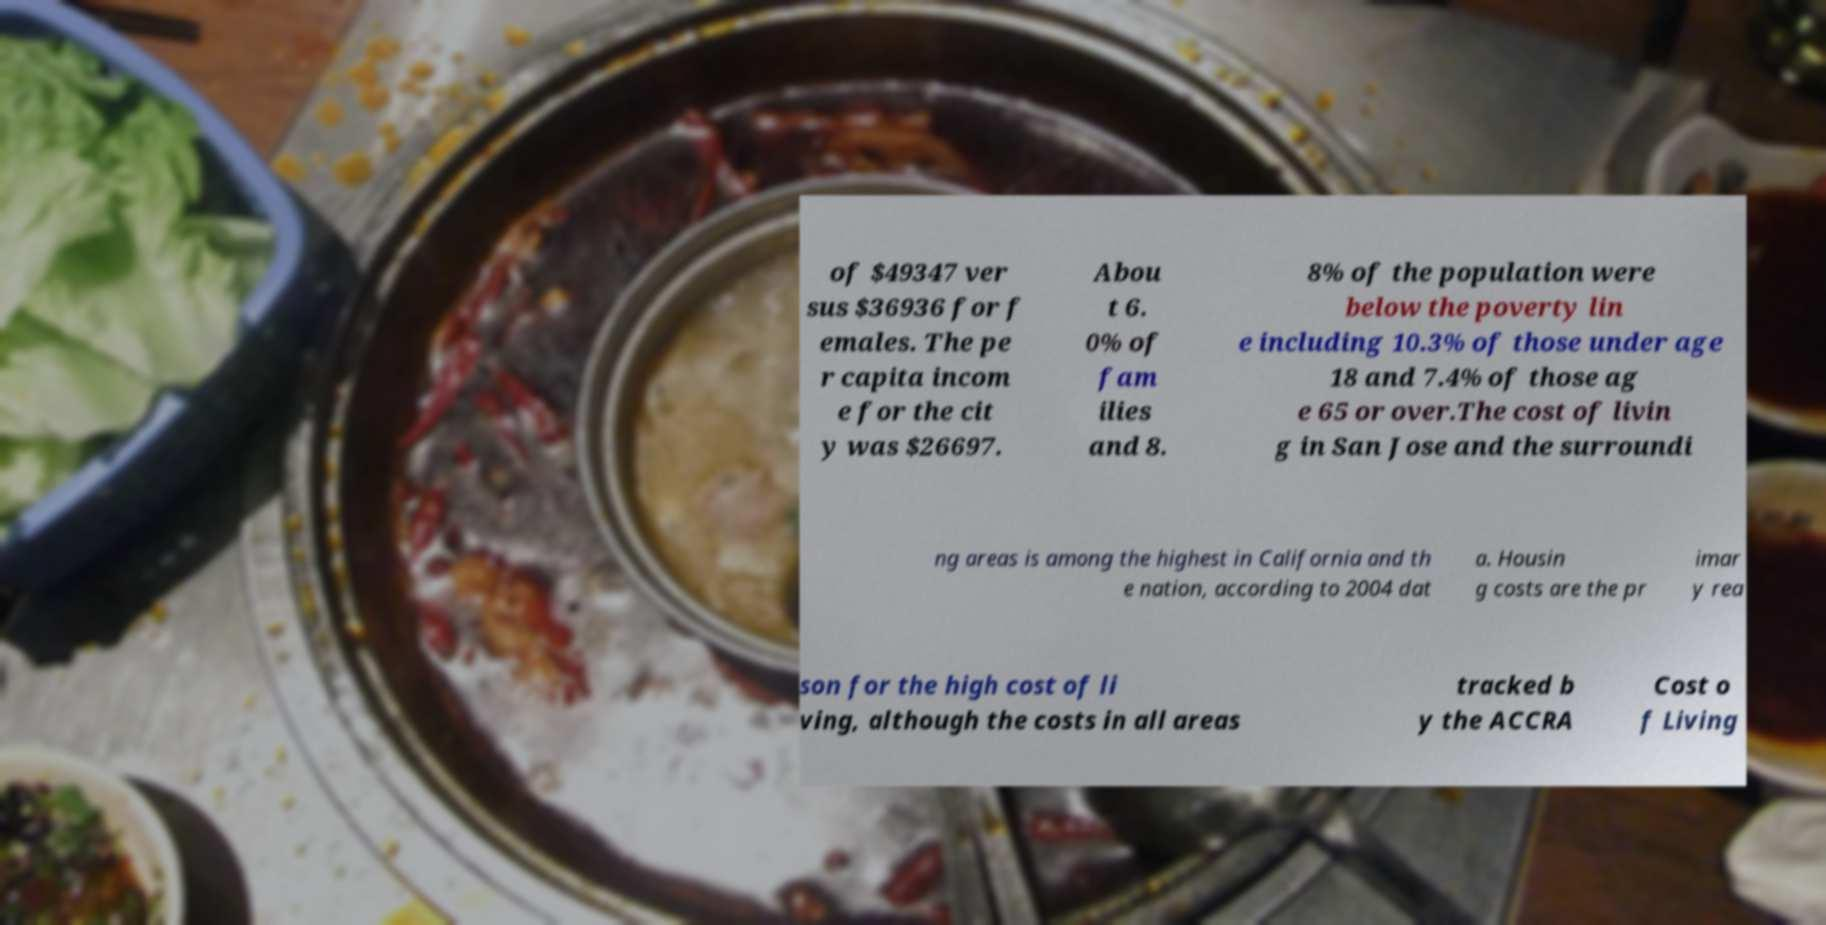Could you assist in decoding the text presented in this image and type it out clearly? of $49347 ver sus $36936 for f emales. The pe r capita incom e for the cit y was $26697. Abou t 6. 0% of fam ilies and 8. 8% of the population were below the poverty lin e including 10.3% of those under age 18 and 7.4% of those ag e 65 or over.The cost of livin g in San Jose and the surroundi ng areas is among the highest in California and th e nation, according to 2004 dat a. Housin g costs are the pr imar y rea son for the high cost of li ving, although the costs in all areas tracked b y the ACCRA Cost o f Living 